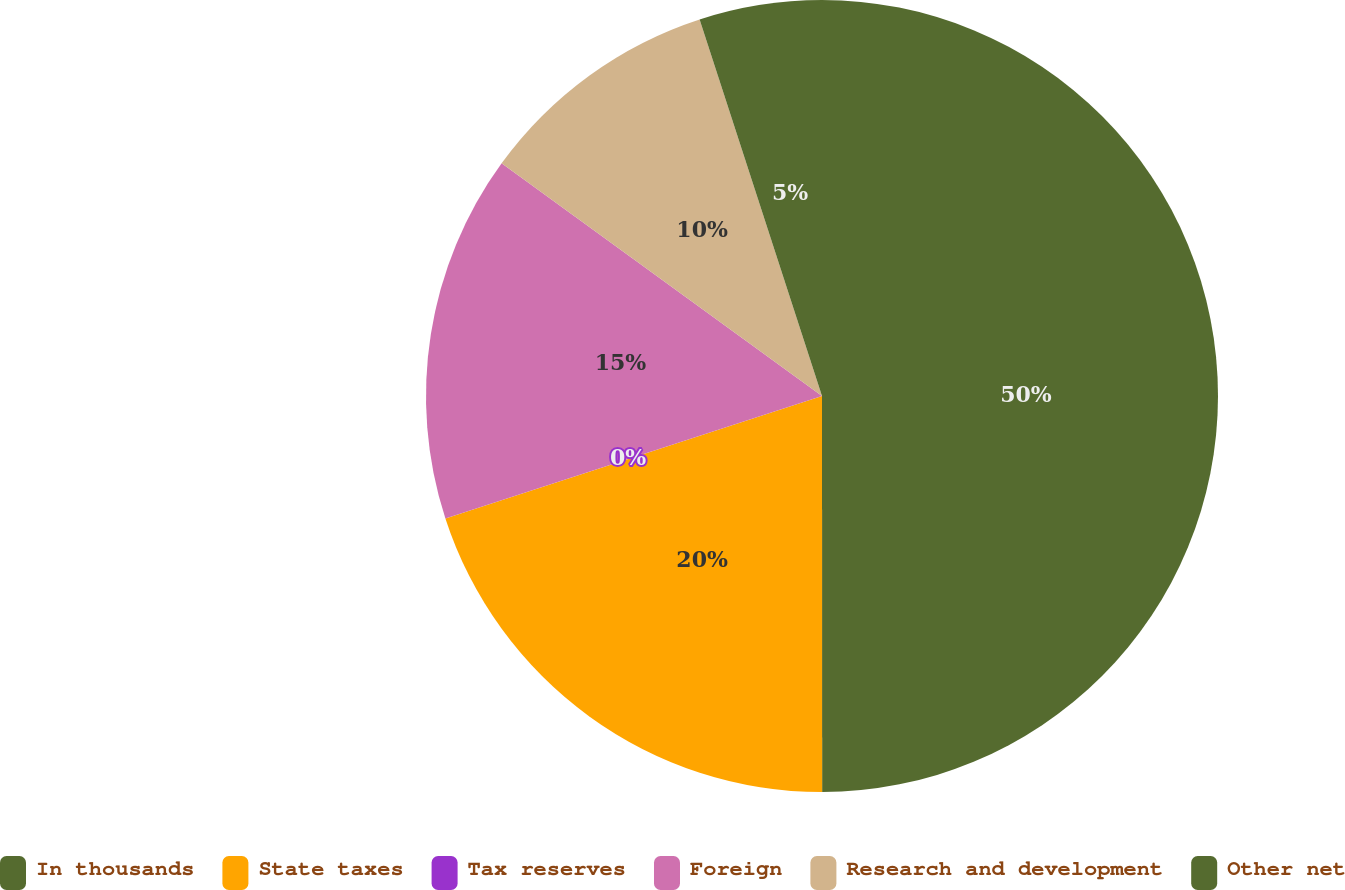<chart> <loc_0><loc_0><loc_500><loc_500><pie_chart><fcel>In thousands<fcel>State taxes<fcel>Tax reserves<fcel>Foreign<fcel>Research and development<fcel>Other net<nl><fcel>49.99%<fcel>20.0%<fcel>0.0%<fcel>15.0%<fcel>10.0%<fcel>5.0%<nl></chart> 